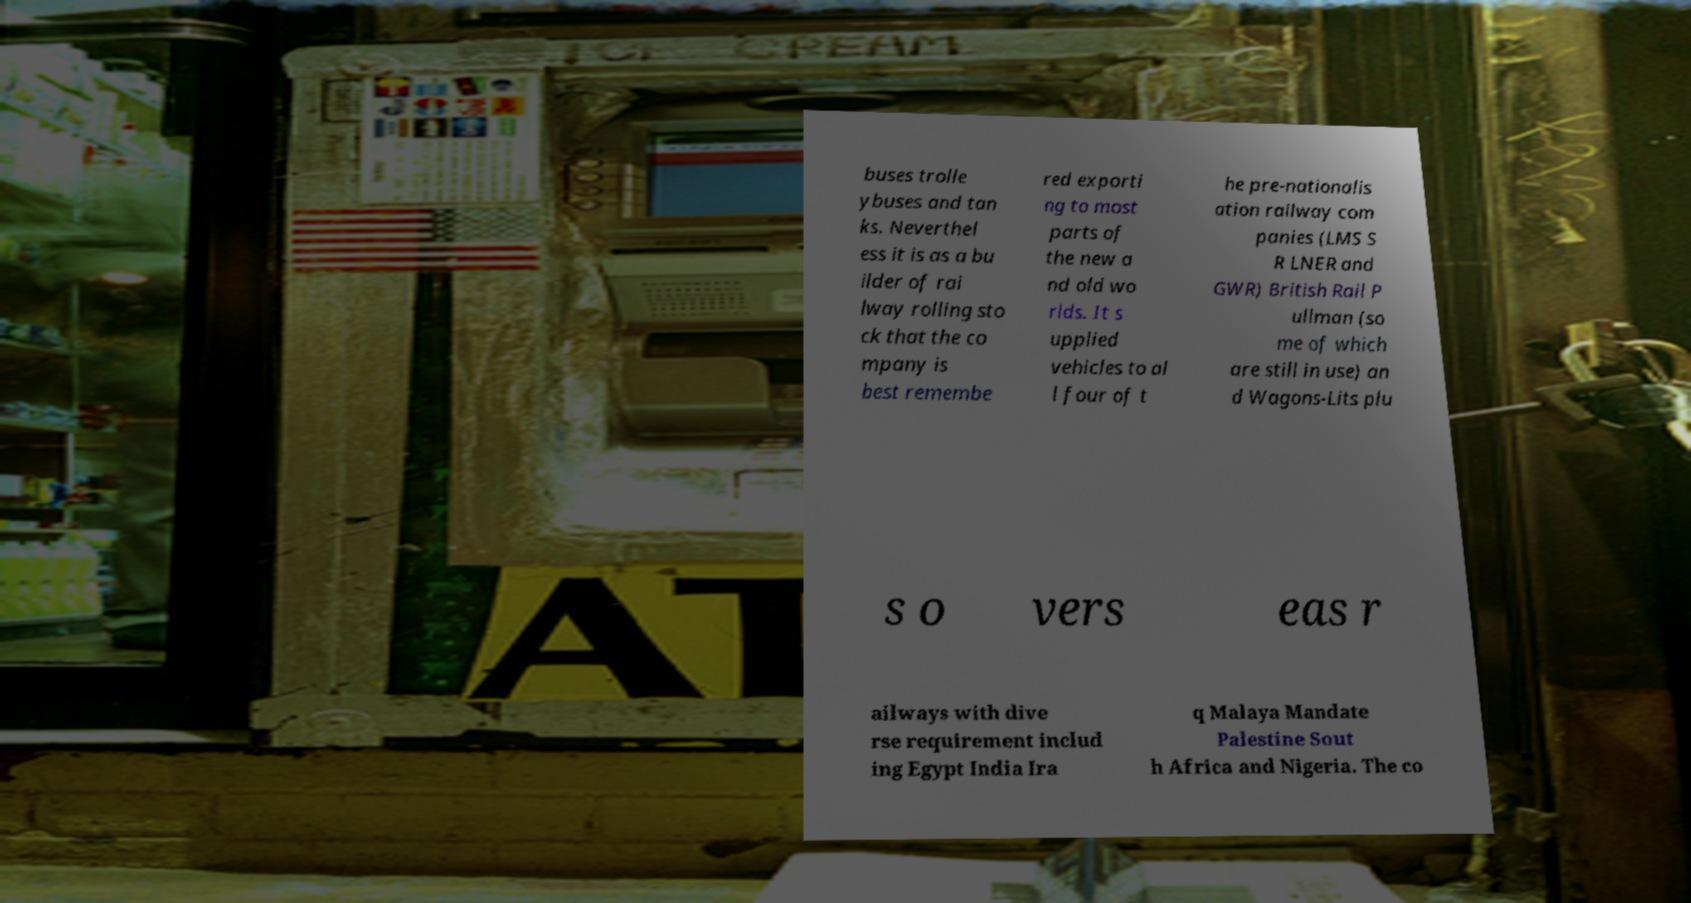I need the written content from this picture converted into text. Can you do that? buses trolle ybuses and tan ks. Neverthel ess it is as a bu ilder of rai lway rolling sto ck that the co mpany is best remembe red exporti ng to most parts of the new a nd old wo rlds. It s upplied vehicles to al l four of t he pre-nationalis ation railway com panies (LMS S R LNER and GWR) British Rail P ullman (so me of which are still in use) an d Wagons-Lits plu s o vers eas r ailways with dive rse requirement includ ing Egypt India Ira q Malaya Mandate Palestine Sout h Africa and Nigeria. The co 